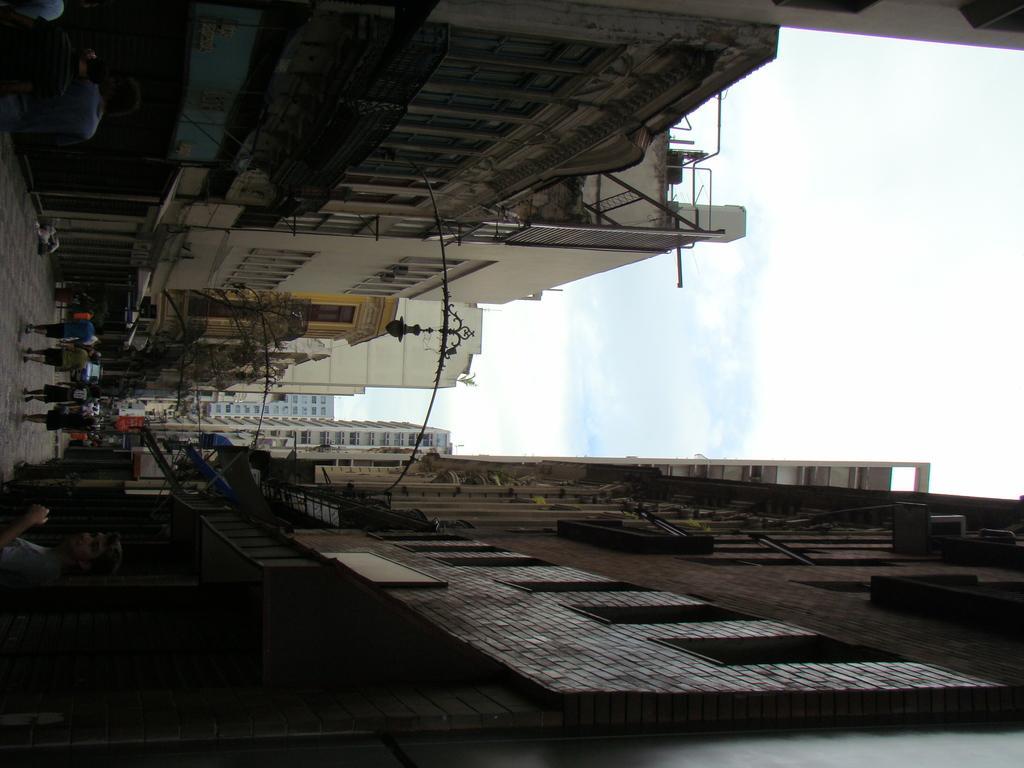In one or two sentences, can you explain what this image depicts? In this image in the middle, there are some people, lights and floor. At the bottom there are buildings. At the top there are buildings. On the right there are sky and clouds. 